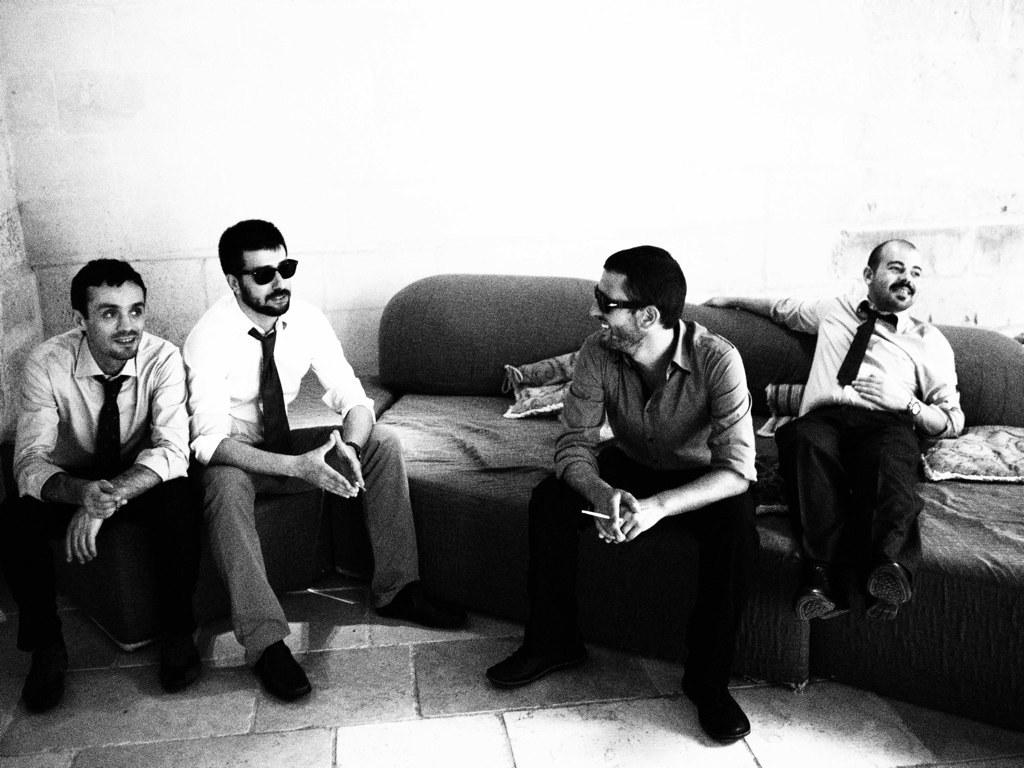What are the people in the image doing? The people in the image are sitting on a couch. What is the facial expression of the people in the image? The people are smiling. What can be seen in the background of the image? There is a wall visible in the background of the image. What type of volleyball game is being played in the image? There is no volleyball game present in the image; it features people sitting on a couch and smiling. Can you tell me the name of the mother in the image? There is no mention of a mother or any specific individuals in the image, only people sitting on a couch and smiling. 